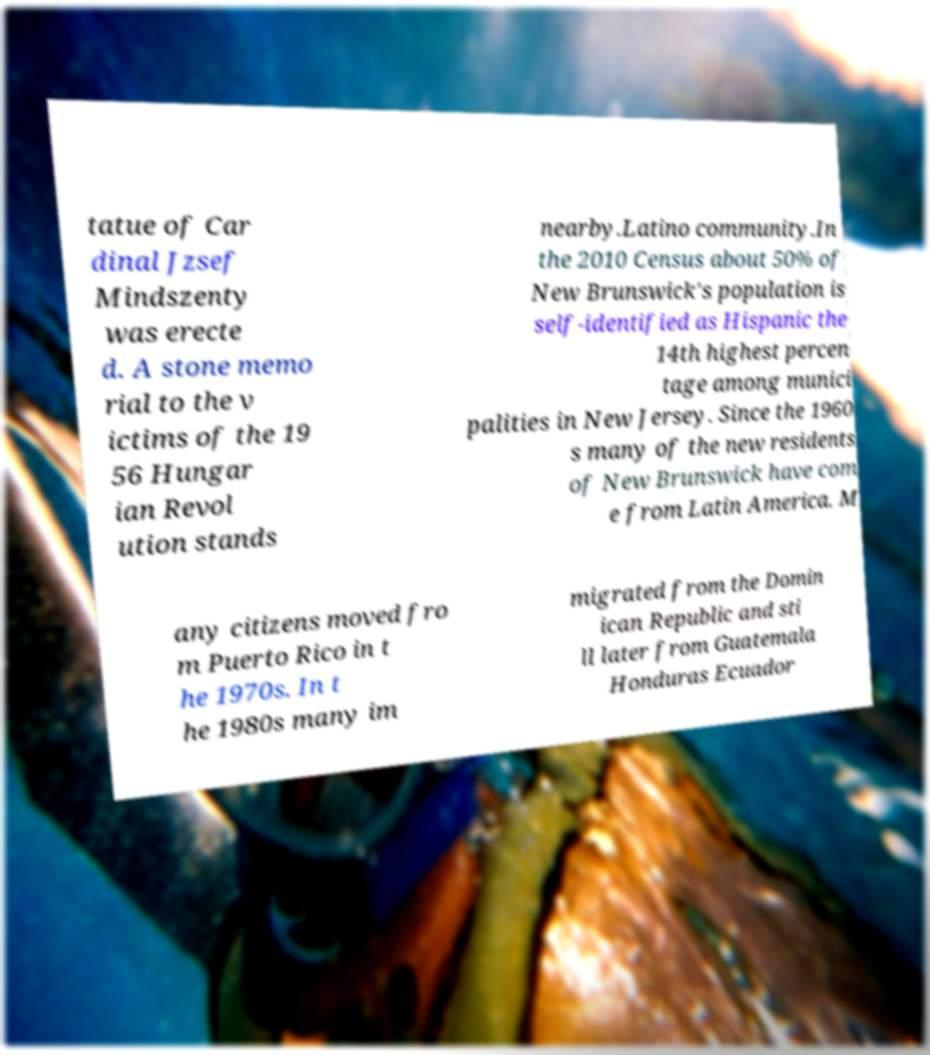Please read and relay the text visible in this image. What does it say? tatue of Car dinal Jzsef Mindszenty was erecte d. A stone memo rial to the v ictims of the 19 56 Hungar ian Revol ution stands nearby.Latino community.In the 2010 Census about 50% of New Brunswick's population is self-identified as Hispanic the 14th highest percen tage among munici palities in New Jersey. Since the 1960 s many of the new residents of New Brunswick have com e from Latin America. M any citizens moved fro m Puerto Rico in t he 1970s. In t he 1980s many im migrated from the Domin ican Republic and sti ll later from Guatemala Honduras Ecuador 